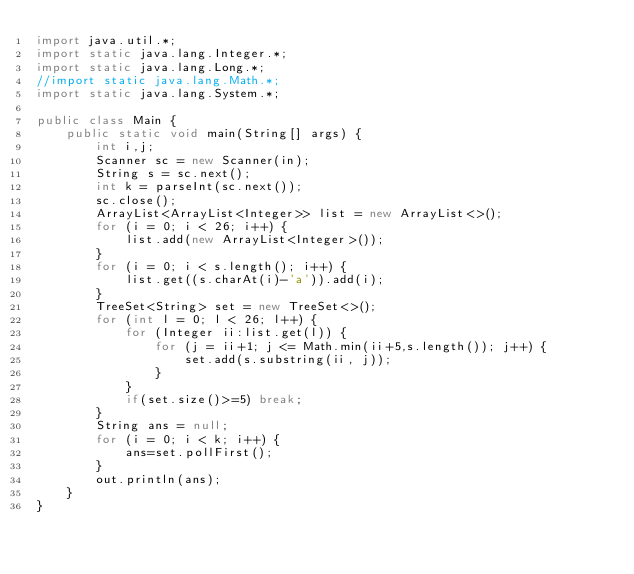Convert code to text. <code><loc_0><loc_0><loc_500><loc_500><_Java_>import java.util.*;
import static java.lang.Integer.*;
import static java.lang.Long.*;
//import static java.lang.Math.*;
import static java.lang.System.*;

public class Main {
	public static void main(String[] args) {
		int i,j;
		Scanner sc = new Scanner(in);
		String s = sc.next();
		int k = parseInt(sc.next());
		sc.close();
		ArrayList<ArrayList<Integer>> list = new ArrayList<>();
		for (i = 0; i < 26; i++) {
			list.add(new ArrayList<Integer>());
		}
		for (i = 0; i < s.length(); i++) {
			list.get((s.charAt(i)-'a')).add(i);
		}
		TreeSet<String> set = new TreeSet<>();
		for (int l = 0; l < 26; l++) {
			for (Integer ii:list.get(l)) {
				for (j = ii+1; j <= Math.min(ii+5,s.length()); j++) {
					set.add(s.substring(ii, j));
				}
			}
			if(set.size()>=5) break;
		}
		String ans = null;
		for (i = 0; i < k; i++) {
			ans=set.pollFirst();
		}
		out.println(ans);
	}
}</code> 